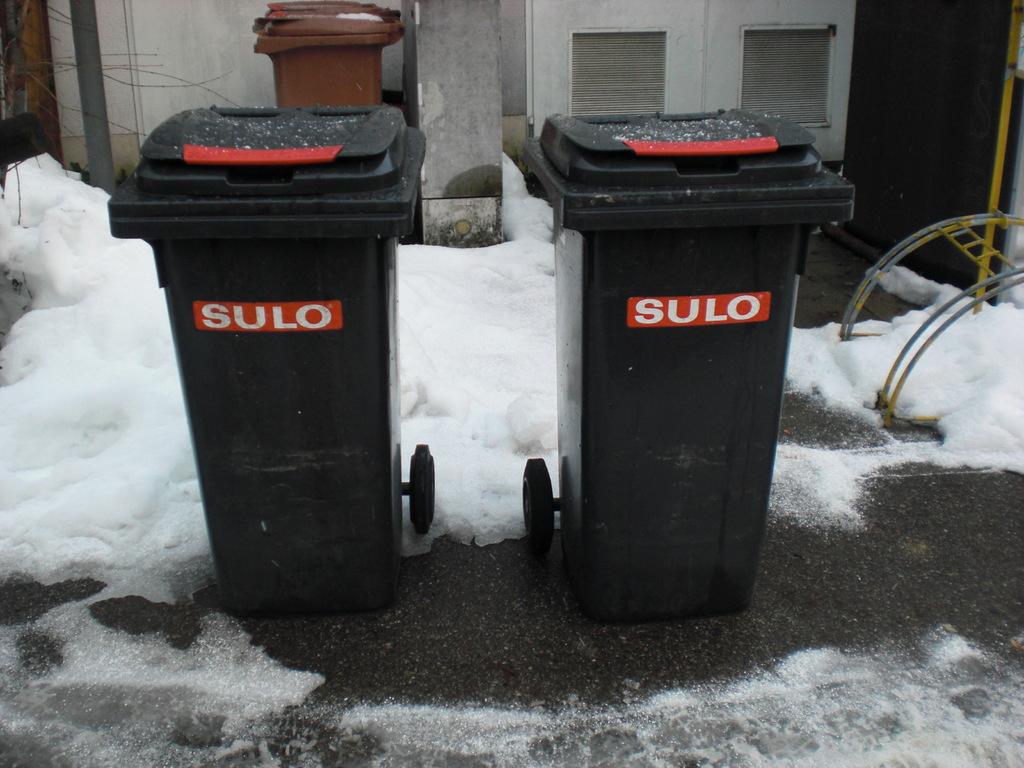What is on the trash can?
Keep it short and to the point. Sulo. What is the first lletter of the word on the trash can?
Offer a very short reply. S. 